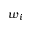Convert formula to latex. <formula><loc_0><loc_0><loc_500><loc_500>w _ { i }</formula> 